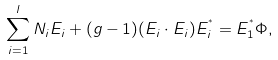Convert formula to latex. <formula><loc_0><loc_0><loc_500><loc_500>\sum _ { i = 1 } ^ { l } N _ { i } E _ { i } + ( g - 1 ) ( E _ { i } \cdot E _ { i } ) E _ { i } ^ { ^ { * } } = E _ { 1 } ^ { ^ { * } } \Phi ,</formula> 